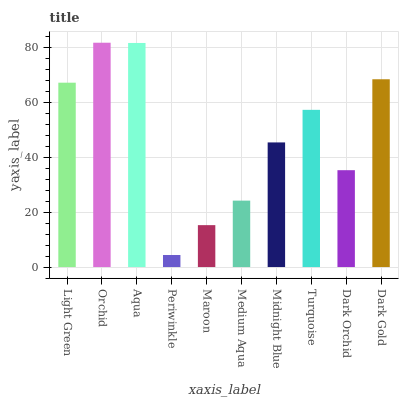Is Periwinkle the minimum?
Answer yes or no. Yes. Is Orchid the maximum?
Answer yes or no. Yes. Is Aqua the minimum?
Answer yes or no. No. Is Aqua the maximum?
Answer yes or no. No. Is Orchid greater than Aqua?
Answer yes or no. Yes. Is Aqua less than Orchid?
Answer yes or no. Yes. Is Aqua greater than Orchid?
Answer yes or no. No. Is Orchid less than Aqua?
Answer yes or no. No. Is Turquoise the high median?
Answer yes or no. Yes. Is Midnight Blue the low median?
Answer yes or no. Yes. Is Aqua the high median?
Answer yes or no. No. Is Maroon the low median?
Answer yes or no. No. 